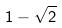Convert formula to latex. <formula><loc_0><loc_0><loc_500><loc_500>1 - \sqrt { 2 }</formula> 